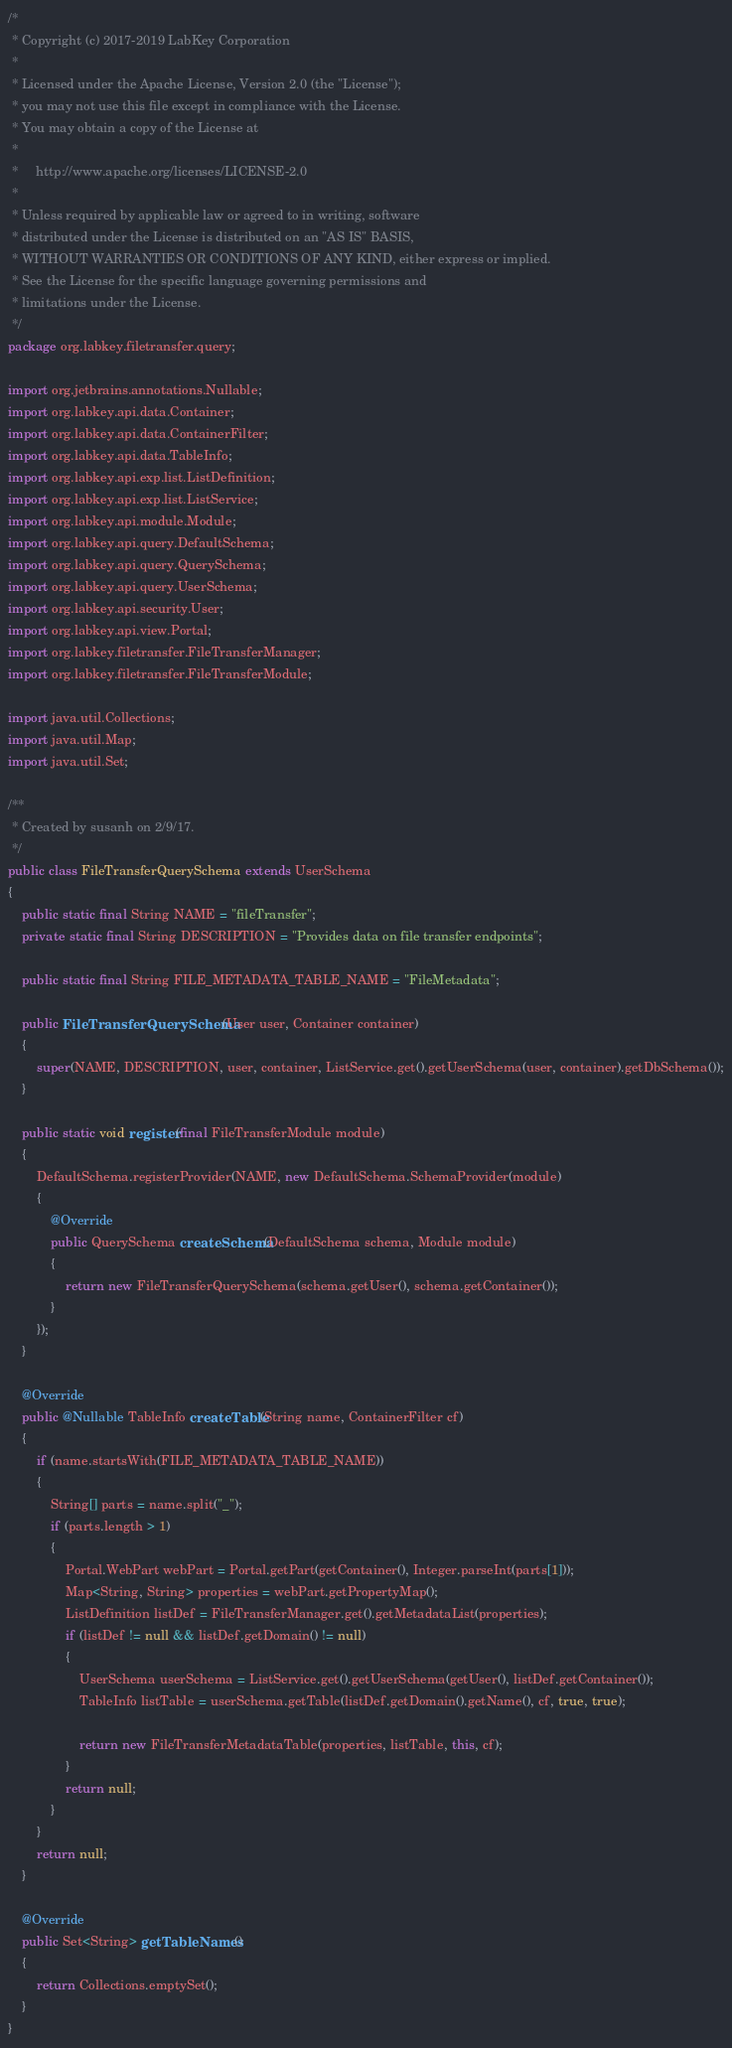Convert code to text. <code><loc_0><loc_0><loc_500><loc_500><_Java_>/*
 * Copyright (c) 2017-2019 LabKey Corporation
 *
 * Licensed under the Apache License, Version 2.0 (the "License");
 * you may not use this file except in compliance with the License.
 * You may obtain a copy of the License at
 *
 *     http://www.apache.org/licenses/LICENSE-2.0
 *
 * Unless required by applicable law or agreed to in writing, software
 * distributed under the License is distributed on an "AS IS" BASIS,
 * WITHOUT WARRANTIES OR CONDITIONS OF ANY KIND, either express or implied.
 * See the License for the specific language governing permissions and
 * limitations under the License.
 */
package org.labkey.filetransfer.query;

import org.jetbrains.annotations.Nullable;
import org.labkey.api.data.Container;
import org.labkey.api.data.ContainerFilter;
import org.labkey.api.data.TableInfo;
import org.labkey.api.exp.list.ListDefinition;
import org.labkey.api.exp.list.ListService;
import org.labkey.api.module.Module;
import org.labkey.api.query.DefaultSchema;
import org.labkey.api.query.QuerySchema;
import org.labkey.api.query.UserSchema;
import org.labkey.api.security.User;
import org.labkey.api.view.Portal;
import org.labkey.filetransfer.FileTransferManager;
import org.labkey.filetransfer.FileTransferModule;

import java.util.Collections;
import java.util.Map;
import java.util.Set;

/**
 * Created by susanh on 2/9/17.
 */
public class FileTransferQuerySchema extends UserSchema
{
    public static final String NAME = "fileTransfer";
    private static final String DESCRIPTION = "Provides data on file transfer endpoints";

    public static final String FILE_METADATA_TABLE_NAME = "FileMetadata";

    public FileTransferQuerySchema(User user, Container container)
    {
        super(NAME, DESCRIPTION, user, container, ListService.get().getUserSchema(user, container).getDbSchema());
    }

    public static void register(final FileTransferModule module)
    {
        DefaultSchema.registerProvider(NAME, new DefaultSchema.SchemaProvider(module)
        {
            @Override
            public QuerySchema createSchema(DefaultSchema schema, Module module)
            {
                return new FileTransferQuerySchema(schema.getUser(), schema.getContainer());
            }
        });
    }

    @Override
    public @Nullable TableInfo createTable(String name, ContainerFilter cf)
    {
        if (name.startsWith(FILE_METADATA_TABLE_NAME))
        {
            String[] parts = name.split("_");
            if (parts.length > 1)
            {
                Portal.WebPart webPart = Portal.getPart(getContainer(), Integer.parseInt(parts[1]));
                Map<String, String> properties = webPart.getPropertyMap();
                ListDefinition listDef = FileTransferManager.get().getMetadataList(properties);
                if (listDef != null && listDef.getDomain() != null)
                {
                    UserSchema userSchema = ListService.get().getUserSchema(getUser(), listDef.getContainer());
                    TableInfo listTable = userSchema.getTable(listDef.getDomain().getName(), cf, true, true);

                    return new FileTransferMetadataTable(properties, listTable, this, cf);
                }
                return null;
            }
        }
        return null;
    }

    @Override
    public Set<String> getTableNames()
    {
        return Collections.emptySet();
    }
}
</code> 